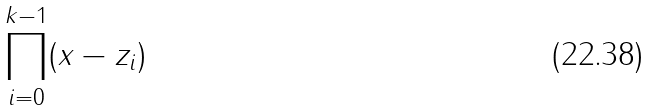<formula> <loc_0><loc_0><loc_500><loc_500>\prod _ { i = 0 } ^ { k - 1 } ( x - z _ { i } )</formula> 